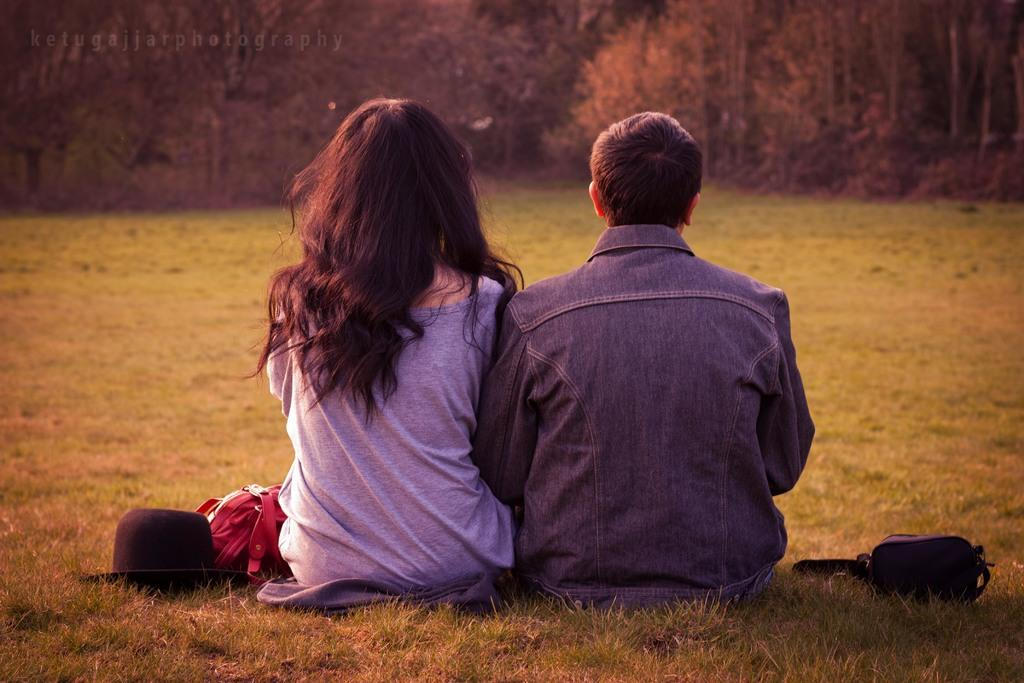Who can be seen in the image? There is a man and a woman in the image. What are they doing in the image? Both the man and woman are sitting on the grassland. What is present on either side of them? There are bags on either side of them. What can be seen in the front of the image? There are trees in the front of the image. What type of dinosaurs can be seen in the image? There are no dinosaurs present in the image. What are the man and woman cooking in the image? There is no cooking activity depicted in the image. 